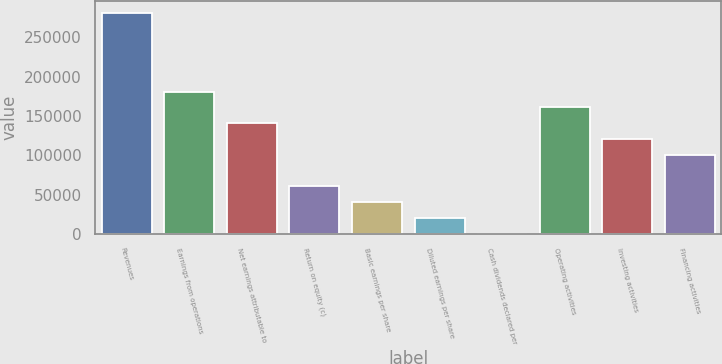Convert chart to OTSL. <chart><loc_0><loc_0><loc_500><loc_500><bar_chart><fcel>Revenues<fcel>Earnings from operations<fcel>Net earnings attributable to<fcel>Return on equity (c)<fcel>Basic earnings per share<fcel>Diluted earnings per share<fcel>Cash dividends declared per<fcel>Operating activities<fcel>Investing activities<fcel>Financing activities<nl><fcel>281621<fcel>181043<fcel>140812<fcel>60349.7<fcel>40234.1<fcel>20118.5<fcel>2.88<fcel>160928<fcel>120697<fcel>100581<nl></chart> 